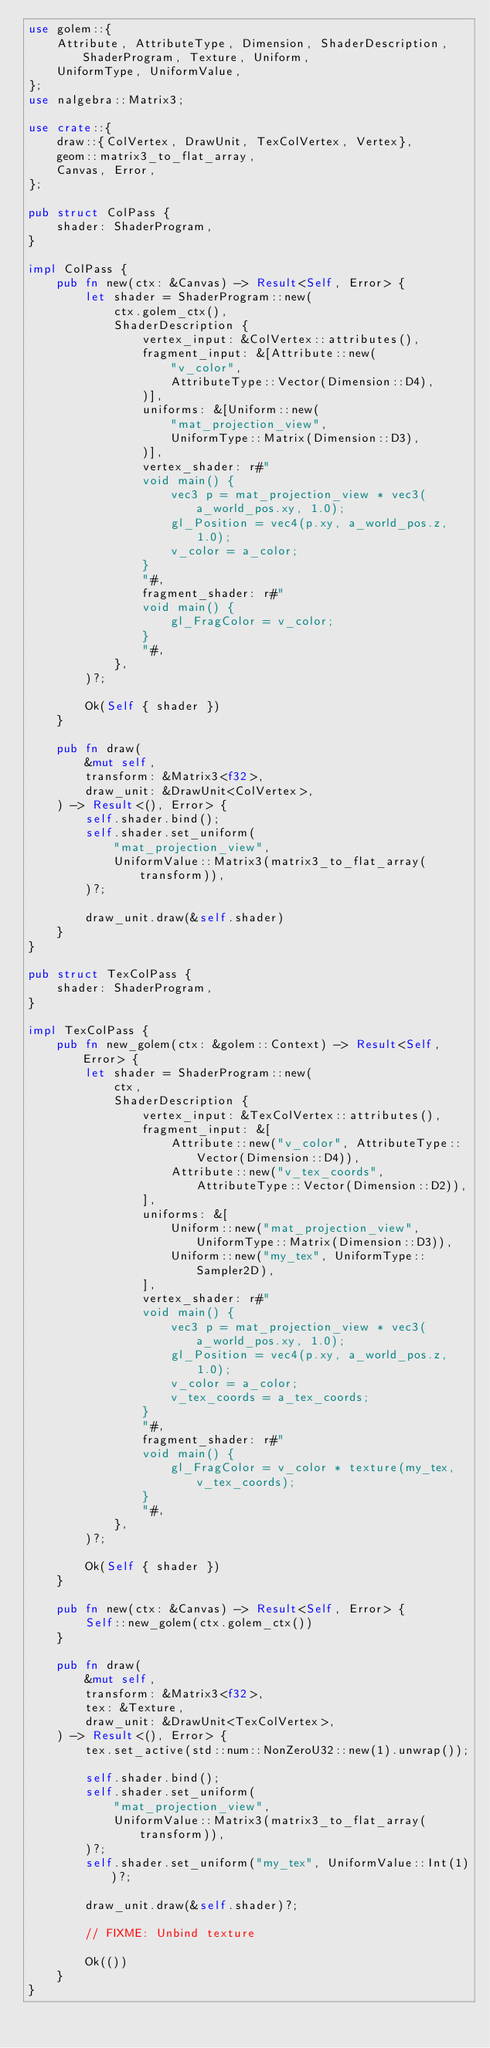Convert code to text. <code><loc_0><loc_0><loc_500><loc_500><_Rust_>use golem::{
    Attribute, AttributeType, Dimension, ShaderDescription, ShaderProgram, Texture, Uniform,
    UniformType, UniformValue,
};
use nalgebra::Matrix3;

use crate::{
    draw::{ColVertex, DrawUnit, TexColVertex, Vertex},
    geom::matrix3_to_flat_array,
    Canvas, Error,
};

pub struct ColPass {
    shader: ShaderProgram,
}

impl ColPass {
    pub fn new(ctx: &Canvas) -> Result<Self, Error> {
        let shader = ShaderProgram::new(
            ctx.golem_ctx(),
            ShaderDescription {
                vertex_input: &ColVertex::attributes(),
                fragment_input: &[Attribute::new(
                    "v_color",
                    AttributeType::Vector(Dimension::D4),
                )],
                uniforms: &[Uniform::new(
                    "mat_projection_view",
                    UniformType::Matrix(Dimension::D3),
                )],
                vertex_shader: r#"
                void main() {
                    vec3 p = mat_projection_view * vec3(a_world_pos.xy, 1.0);
                    gl_Position = vec4(p.xy, a_world_pos.z, 1.0);
                    v_color = a_color;
                }
                "#,
                fragment_shader: r#"
                void main() {
                    gl_FragColor = v_color;
                }
                "#,
            },
        )?;

        Ok(Self { shader })
    }

    pub fn draw(
        &mut self,
        transform: &Matrix3<f32>,
        draw_unit: &DrawUnit<ColVertex>,
    ) -> Result<(), Error> {
        self.shader.bind();
        self.shader.set_uniform(
            "mat_projection_view",
            UniformValue::Matrix3(matrix3_to_flat_array(transform)),
        )?;

        draw_unit.draw(&self.shader)
    }
}

pub struct TexColPass {
    shader: ShaderProgram,
}

impl TexColPass {
    pub fn new_golem(ctx: &golem::Context) -> Result<Self, Error> {
        let shader = ShaderProgram::new(
            ctx,
            ShaderDescription {
                vertex_input: &TexColVertex::attributes(),
                fragment_input: &[
                    Attribute::new("v_color", AttributeType::Vector(Dimension::D4)),
                    Attribute::new("v_tex_coords", AttributeType::Vector(Dimension::D2)),
                ],
                uniforms: &[
                    Uniform::new("mat_projection_view", UniformType::Matrix(Dimension::D3)),
                    Uniform::new("my_tex", UniformType::Sampler2D),
                ],
                vertex_shader: r#"
                void main() {
                    vec3 p = mat_projection_view * vec3(a_world_pos.xy, 1.0);
                    gl_Position = vec4(p.xy, a_world_pos.z, 1.0);
                    v_color = a_color;
                    v_tex_coords = a_tex_coords;
                }
                "#,
                fragment_shader: r#"
                void main() {
                    gl_FragColor = v_color * texture(my_tex, v_tex_coords);
                }
                "#,
            },
        )?;

        Ok(Self { shader })
    }

    pub fn new(ctx: &Canvas) -> Result<Self, Error> {
        Self::new_golem(ctx.golem_ctx())
    }

    pub fn draw(
        &mut self,
        transform: &Matrix3<f32>,
        tex: &Texture,
        draw_unit: &DrawUnit<TexColVertex>,
    ) -> Result<(), Error> {
        tex.set_active(std::num::NonZeroU32::new(1).unwrap());

        self.shader.bind();
        self.shader.set_uniform(
            "mat_projection_view",
            UniformValue::Matrix3(matrix3_to_flat_array(transform)),
        )?;
        self.shader.set_uniform("my_tex", UniformValue::Int(1))?;

        draw_unit.draw(&self.shader)?;

        // FIXME: Unbind texture

        Ok(())
    }
}
</code> 